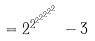<formula> <loc_0><loc_0><loc_500><loc_500>= { 2 ^ { 2 ^ { 2 ^ { 2 ^ { 2 ^ { 2 ^ { 2 } } } } } } } - 3</formula> 